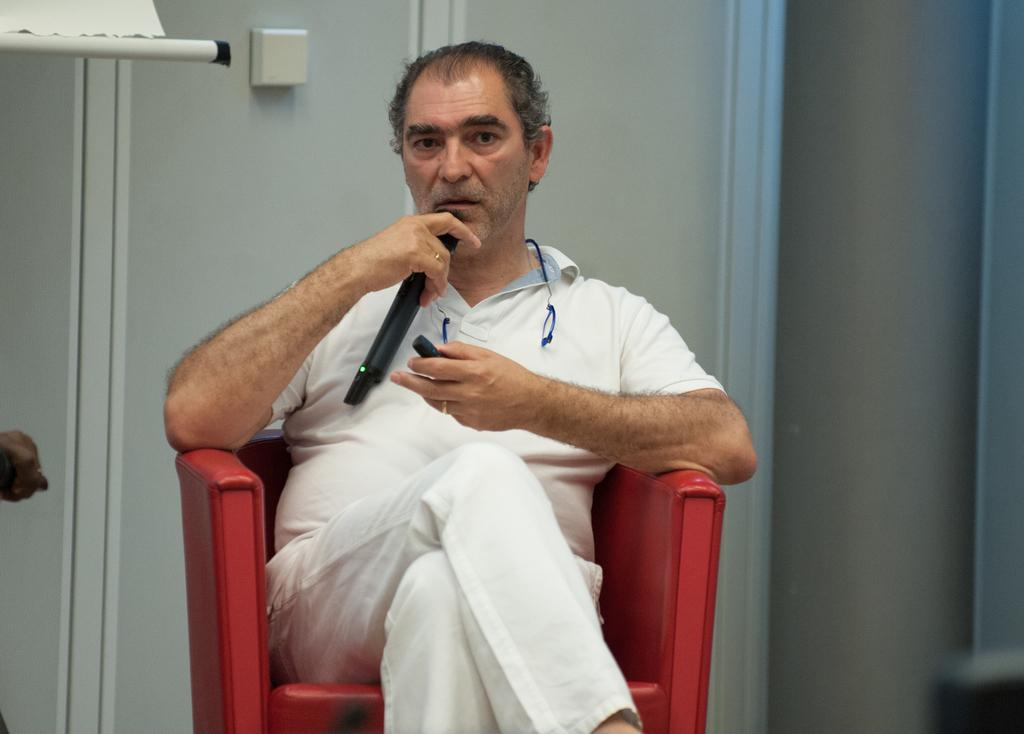What is the main subject of the image? The main subject of the image is a man. What is the man doing in the image? The man is sitting on a chair in the image. What object is the man holding in his hand? The man is holding a mic in one of his hands. What type of order is the man following in the image? There is no indication in the image that the man is following any specific order. How many hands does the man have in the image? The man has two hands in the image. --- 